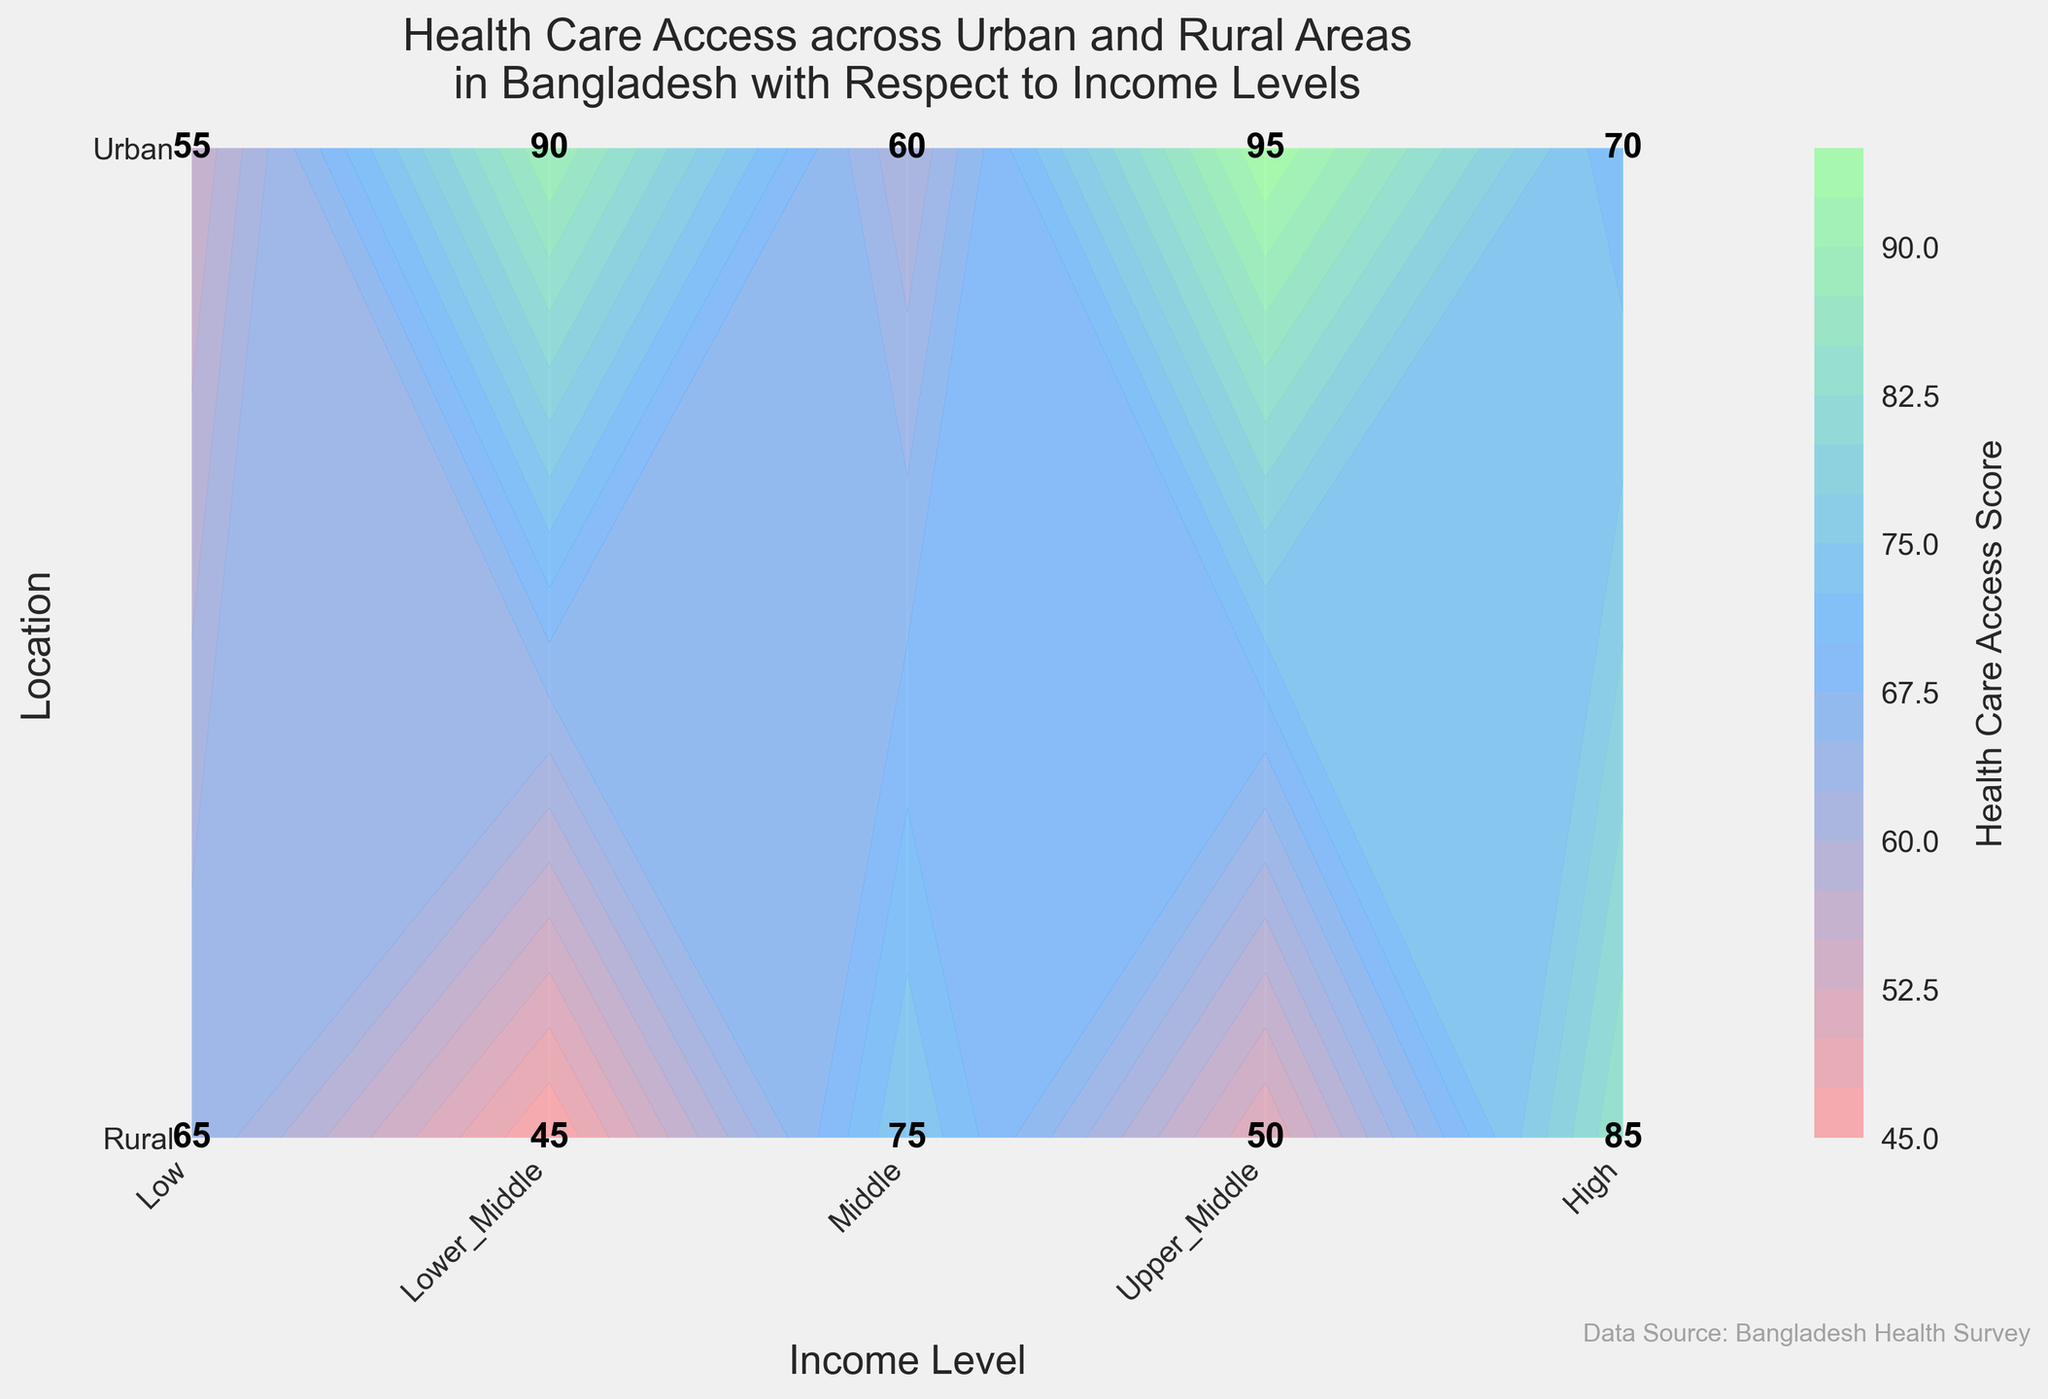What is the title of the figure? The title can be found at the top of the figure, clearly stating the content and context of the data being presented.
Answer: Health Care Access across Urban and Rural Areas in Bangladesh with Respect to Income Levels What does the color bar represent? The color bar on the side of the figure indicates the range of Health Care Access Scores. The colors change progressively as the scores increase or decrease.
Answer: Health Care Access Score Which location has higher health care access scores, Urban or Rural? By examining the health care access scores for each income level, it is clear that Urban areas consistently have higher scores compared to Rural areas.
Answer: Urban What is the health care access score for High-income level in Rural areas? Locate the intersection of the "High" income level (the rightmost point on the x-axis) and "Rural" location (the bottom point on the y-axis), the number indicated is the health care access score.
Answer: 70 How much higher is the health care access score for Urban areas than Rural areas at the Middle-income level? Find the health care access scores for both Urban and Rural areas at the Middle-income level. Then, subtract the Rural score from the Urban score to determine the difference.
Answer: 30 (85 - 55) What pattern do you see between income levels and health care access scores in Urban areas? As we move from Low-income to High-income levels on the x-axis for Urban areas, the health care access scores increase, showing a positive correlation between income levels and health care access in Urban areas.
Answer: Increasing Can you identify a trend in health care access scores as income level increases from Low to High for Rural areas? By examining the progression of scores from "Low" to "High" for Rural areas, there is a noticeable increase in health care access scores, indicating a positive relationship between income levels and health care access.
Answer: Increasing What is the relationship between Health Care Access Score and income level in Urban areas compared to Rural areas? In Urban areas, the health care access scores are higher at each income level compared to Rural areas. This suggests that increasing income positively influences health care access in both locations, but Urban areas benefit more.
Answer: Urban areas have consistently higher scores Which location and income level combination has the highest health care access score? Locate the point on the contour plot with the highest health care access score indicated. This will be at the intersection of Urban areas and High-income level.
Answer: Urban, High-income level 